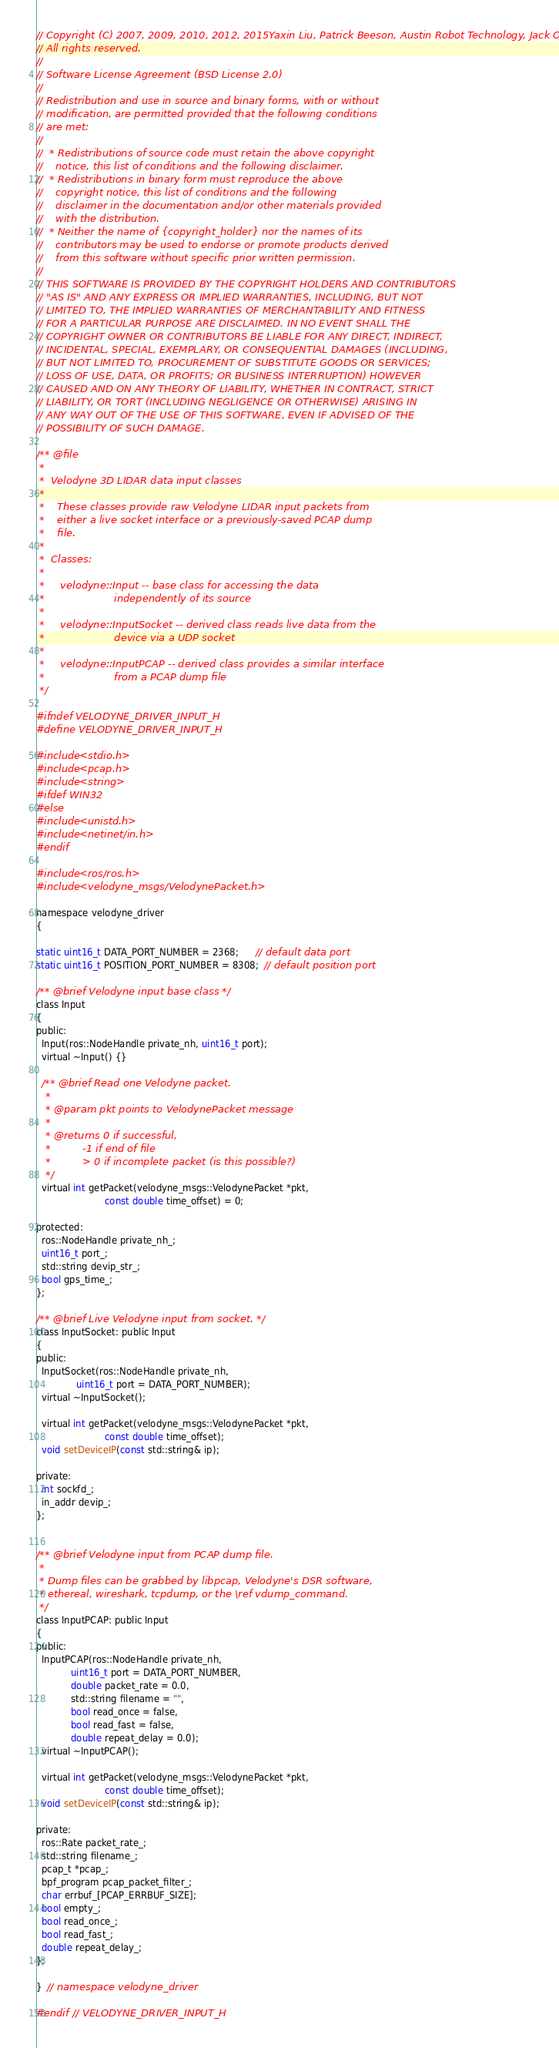Convert code to text. <code><loc_0><loc_0><loc_500><loc_500><_C_>// Copyright (C) 2007, 2009, 2010, 2012, 2015Yaxin Liu, Patrick Beeson, Austin Robot Technology, Jack O'Quin
// All rights reserved.
//
// Software License Agreement (BSD License 2.0)
//
// Redistribution and use in source and binary forms, with or without
// modification, are permitted provided that the following conditions
// are met:
//
//  * Redistributions of source code must retain the above copyright
//    notice, this list of conditions and the following disclaimer.
//  * Redistributions in binary form must reproduce the above
//    copyright notice, this list of conditions and the following
//    disclaimer in the documentation and/or other materials provided
//    with the distribution.
//  * Neither the name of {copyright_holder} nor the names of its
//    contributors may be used to endorse or promote products derived
//    from this software without specific prior written permission.
//
// THIS SOFTWARE IS PROVIDED BY THE COPYRIGHT HOLDERS AND CONTRIBUTORS
// "AS IS" AND ANY EXPRESS OR IMPLIED WARRANTIES, INCLUDING, BUT NOT
// LIMITED TO, THE IMPLIED WARRANTIES OF MERCHANTABILITY AND FITNESS
// FOR A PARTICULAR PURPOSE ARE DISCLAIMED. IN NO EVENT SHALL THE
// COPYRIGHT OWNER OR CONTRIBUTORS BE LIABLE FOR ANY DIRECT, INDIRECT,
// INCIDENTAL, SPECIAL, EXEMPLARY, OR CONSEQUENTIAL DAMAGES (INCLUDING,
// BUT NOT LIMITED TO, PROCUREMENT OF SUBSTITUTE GOODS OR SERVICES;
// LOSS OF USE, DATA, OR PROFITS; OR BUSINESS INTERRUPTION) HOWEVER
// CAUSED AND ON ANY THEORY OF LIABILITY, WHETHER IN CONTRACT, STRICT
// LIABILITY, OR TORT (INCLUDING NEGLIGENCE OR OTHERWISE) ARISING IN
// ANY WAY OUT OF THE USE OF THIS SOFTWARE, EVEN IF ADVISED OF THE
// POSSIBILITY OF SUCH DAMAGE.

/** @file
 *
 *  Velodyne 3D LIDAR data input classes
 *
 *    These classes provide raw Velodyne LIDAR input packets from
 *    either a live socket interface or a previously-saved PCAP dump
 *    file.
 *
 *  Classes:
 *
 *     velodyne::Input -- base class for accessing the data
 *                      independently of its source
 *
 *     velodyne::InputSocket -- derived class reads live data from the
 *                      device via a UDP socket
 *
 *     velodyne::InputPCAP -- derived class provides a similar interface
 *                      from a PCAP dump file
 */

#ifndef VELODYNE_DRIVER_INPUT_H
#define VELODYNE_DRIVER_INPUT_H

#include <stdio.h>
#include <pcap.h>
#include <string>
#ifdef WIN32
#else
#include <unistd.h>
#include <netinet/in.h>
#endif

#include <ros/ros.h>
#include <velodyne_msgs/VelodynePacket.h>

namespace velodyne_driver
{

static uint16_t DATA_PORT_NUMBER = 2368;      // default data port
static uint16_t POSITION_PORT_NUMBER = 8308;  // default position port

/** @brief Velodyne input base class */
class Input
{
public:
  Input(ros::NodeHandle private_nh, uint16_t port);
  virtual ~Input() {}

  /** @brief Read one Velodyne packet.
   *
   * @param pkt points to VelodynePacket message
   *
   * @returns 0 if successful,
   *          -1 if end of file
   *          > 0 if incomplete packet (is this possible?)
   */
  virtual int getPacket(velodyne_msgs::VelodynePacket *pkt,
                        const double time_offset) = 0;

protected:
  ros::NodeHandle private_nh_;
  uint16_t port_;
  std::string devip_str_;
  bool gps_time_;
};

/** @brief Live Velodyne input from socket. */
class InputSocket: public Input
{
public:
  InputSocket(ros::NodeHandle private_nh,
              uint16_t port = DATA_PORT_NUMBER);
  virtual ~InputSocket();

  virtual int getPacket(velodyne_msgs::VelodynePacket *pkt,
                        const double time_offset);
  void setDeviceIP(const std::string& ip);

private:
  int sockfd_;
  in_addr devip_;
};


/** @brief Velodyne input from PCAP dump file.
 *
 * Dump files can be grabbed by libpcap, Velodyne's DSR software,
 * ethereal, wireshark, tcpdump, or the \ref vdump_command.
 */
class InputPCAP: public Input
{
public:
  InputPCAP(ros::NodeHandle private_nh,
            uint16_t port = DATA_PORT_NUMBER,
            double packet_rate = 0.0,
            std::string filename = "",
            bool read_once = false,
            bool read_fast = false,
            double repeat_delay = 0.0);
  virtual ~InputPCAP();

  virtual int getPacket(velodyne_msgs::VelodynePacket *pkt,
                        const double time_offset);
  void setDeviceIP(const std::string& ip);

private:
  ros::Rate packet_rate_;
  std::string filename_;
  pcap_t *pcap_;
  bpf_program pcap_packet_filter_;
  char errbuf_[PCAP_ERRBUF_SIZE];
  bool empty_;
  bool read_once_;
  bool read_fast_;
  double repeat_delay_;
};

}  // namespace velodyne_driver

#endif  // VELODYNE_DRIVER_INPUT_H
</code> 